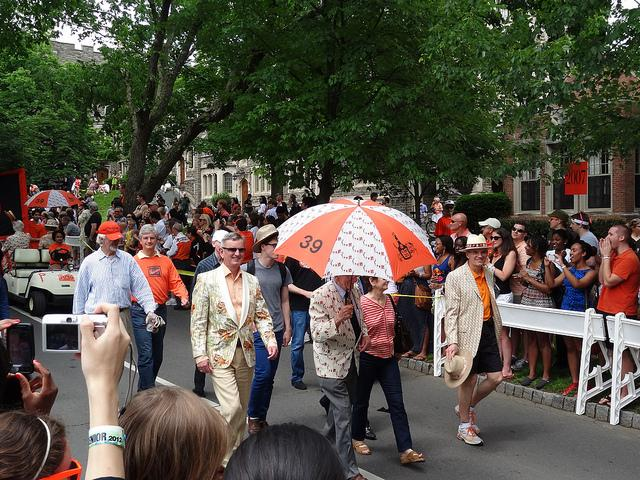What event is being filmed here?

Choices:
A) protest
B) cake walk
C) horse show
D) parade parade 